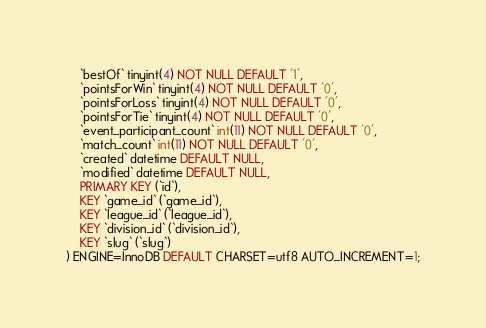<code> <loc_0><loc_0><loc_500><loc_500><_SQL_>	`bestOf` tinyint(4) NOT NULL DEFAULT '1',
	`pointsForWin` tinyint(4) NOT NULL DEFAULT '0',
	`pointsForLoss` tinyint(4) NOT NULL DEFAULT '0',
	`pointsForTie` tinyint(4) NOT NULL DEFAULT '0',
	`event_participant_count` int(11) NOT NULL DEFAULT '0',
	`match_count` int(11) NOT NULL DEFAULT '0',
	`created` datetime DEFAULT NULL,
	`modified` datetime DEFAULT NULL,
	PRIMARY KEY (`id`),
	KEY `game_id` (`game_id`),
	KEY `league_id` (`league_id`),
	KEY `division_id` (`division_id`),
	KEY `slug` (`slug`)
) ENGINE=InnoDB DEFAULT CHARSET=utf8 AUTO_INCREMENT=1;
</code> 